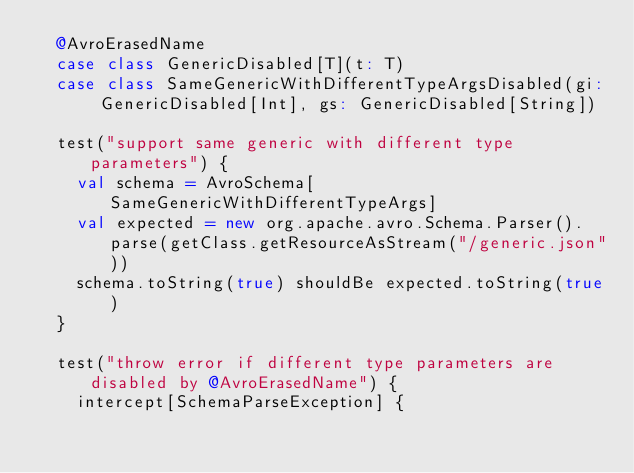<code> <loc_0><loc_0><loc_500><loc_500><_Scala_>  @AvroErasedName
  case class GenericDisabled[T](t: T)
  case class SameGenericWithDifferentTypeArgsDisabled(gi: GenericDisabled[Int], gs: GenericDisabled[String])

  test("support same generic with different type parameters") {
    val schema = AvroSchema[SameGenericWithDifferentTypeArgs]
    val expected = new org.apache.avro.Schema.Parser().parse(getClass.getResourceAsStream("/generic.json"))
    schema.toString(true) shouldBe expected.toString(true)
  }

  test("throw error if different type parameters are disabled by @AvroErasedName") {
    intercept[SchemaParseException] {</code> 